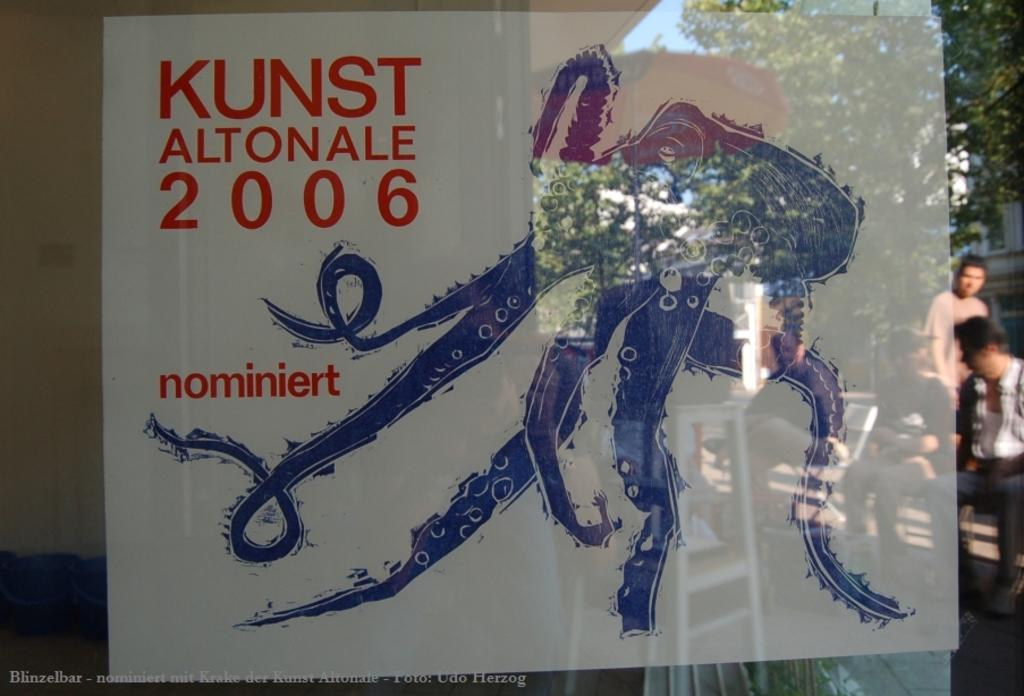<image>
Share a concise interpretation of the image provided. An octopus with the caption Kunst altonale 2006 